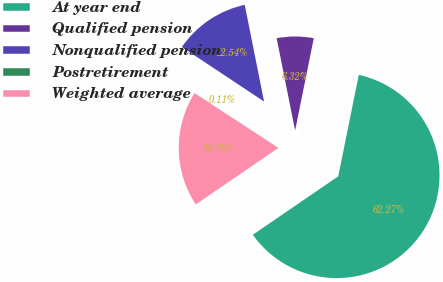Convert chart to OTSL. <chart><loc_0><loc_0><loc_500><loc_500><pie_chart><fcel>At year end<fcel>Qualified pension<fcel>Nonqualified pension<fcel>Postretirement<fcel>Weighted average<nl><fcel>62.27%<fcel>6.32%<fcel>12.54%<fcel>0.11%<fcel>18.76%<nl></chart> 